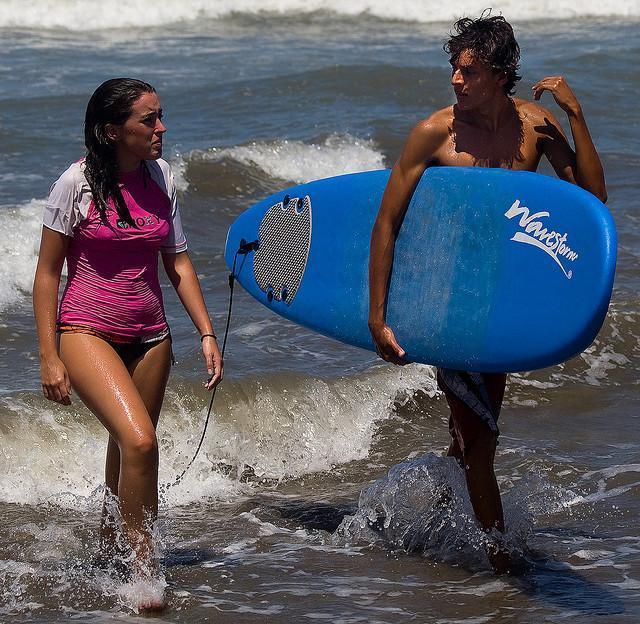How many females in this photo?
Give a very brief answer. 1. How many people are there?
Give a very brief answer. 2. 